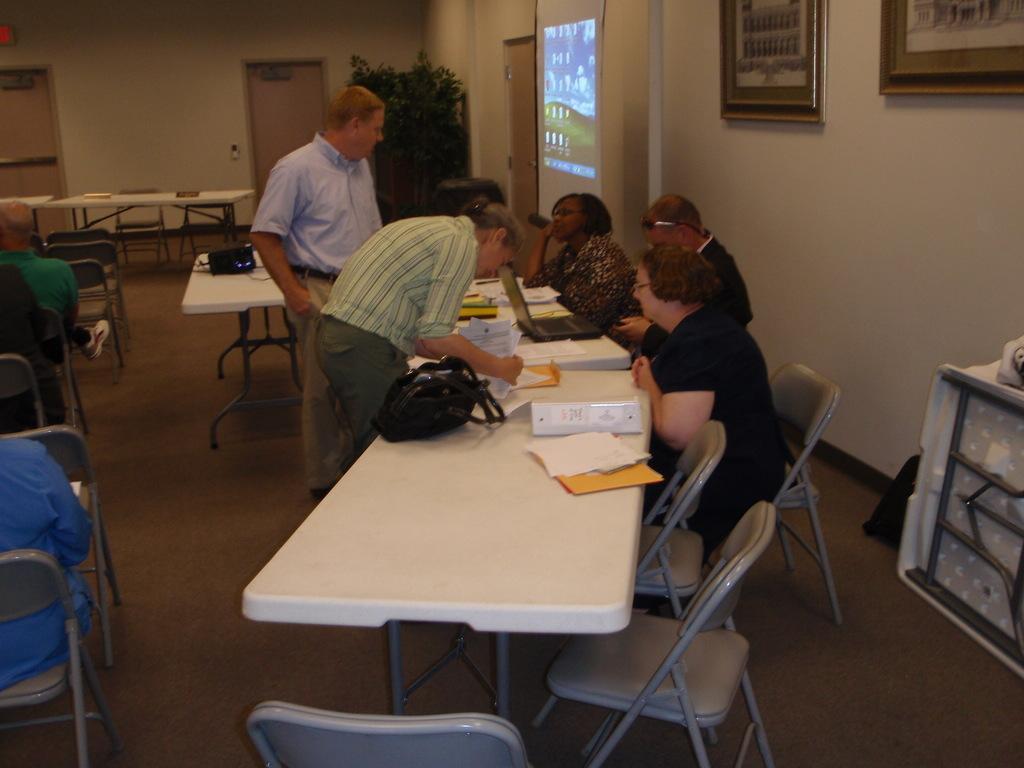In one or two sentences, can you explain what this image depicts? Few persons are sitting on the chairs and these two persons are standing ,this person holding papers. We can see papers,book,bag and objects on the tables. On the background we can see wall,door,screen,frames. This is floor. 